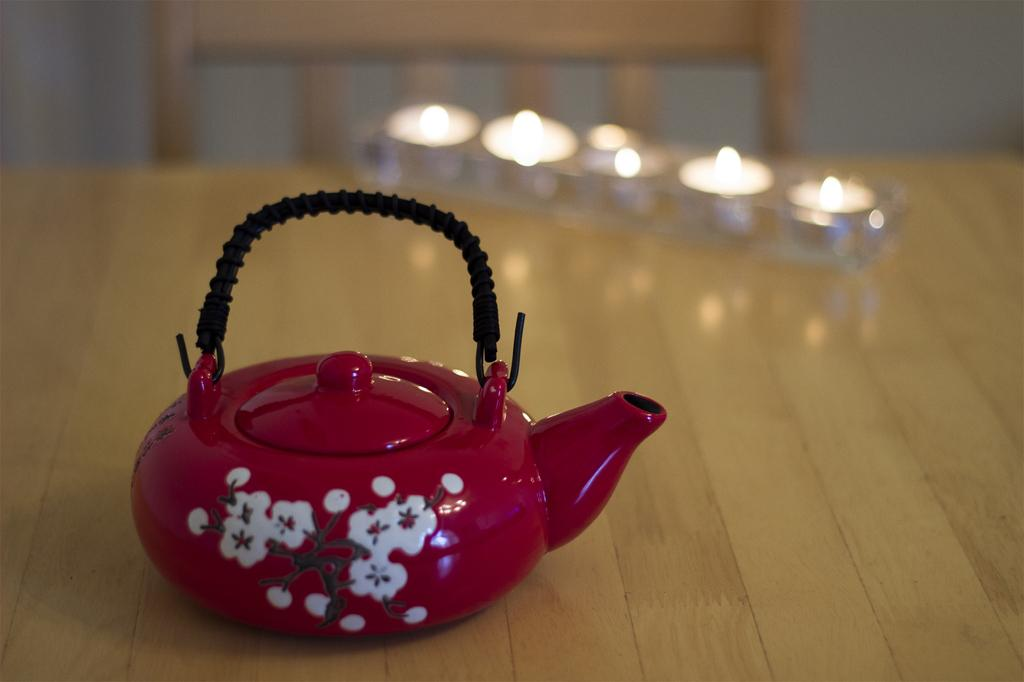What is the main object in the image? There is a teapot in the image. What else can be seen on the table? There are lighted candles on the table. Is there any furniture visible in the image? Yes, there is a chair in the image. How would you describe the background of the image? The background of the image is blurry. How many teeth does the teapot have in the image? The teapot does not have teeth, as it is an inanimate object. 